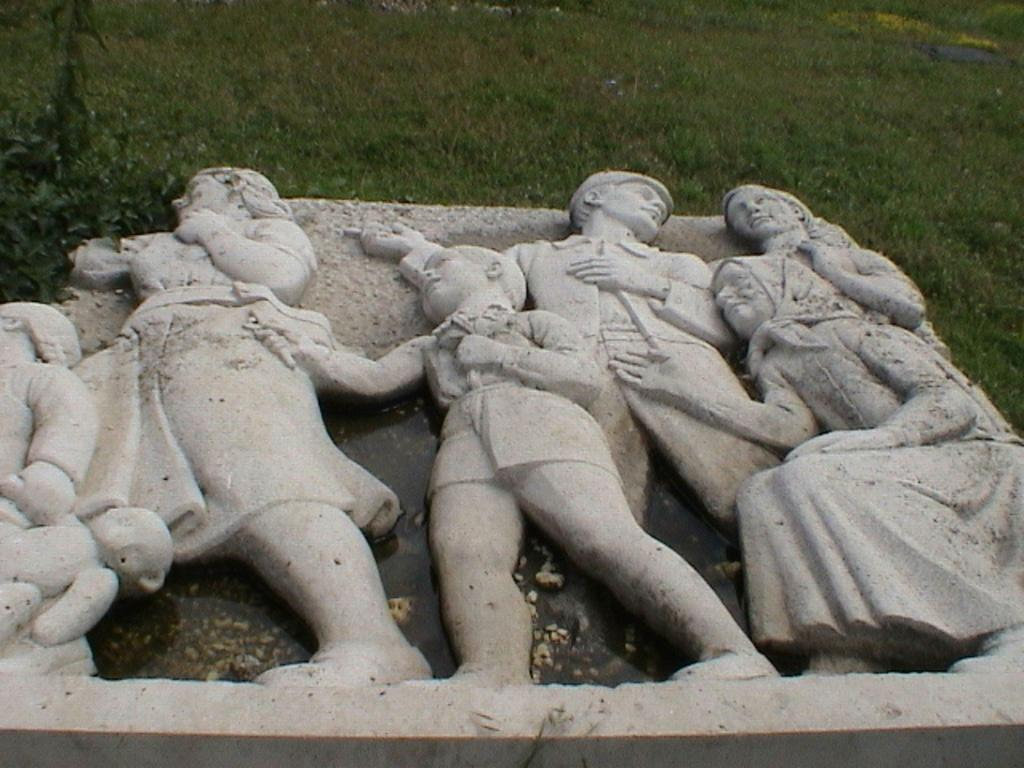What type of figures can be seen in the image? There are human statues in the image. What can be seen in the background of the image? There is grass visible in the background of the image. What type of organization is responsible for the tub in the image? There is no tub present in the image, so it is not possible to determine which organization might be responsible for it. 